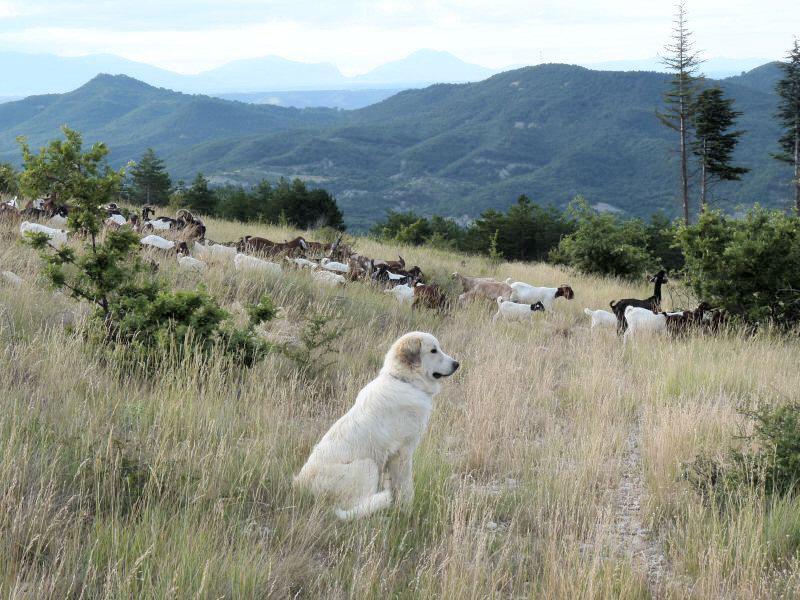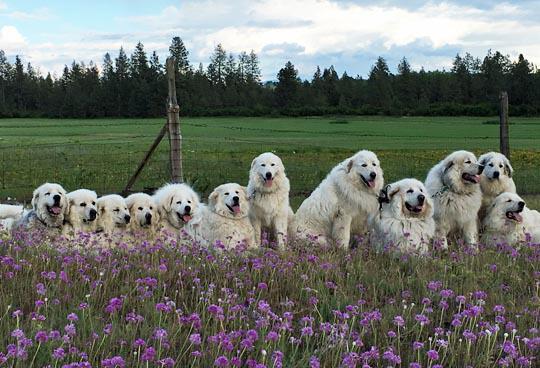The first image is the image on the left, the second image is the image on the right. Assess this claim about the two images: "In one image, one dog is shown with a flock of goats.". Correct or not? Answer yes or no. Yes. The first image is the image on the left, the second image is the image on the right. For the images shown, is this caption "There are exactly two dogs in the image on the right." true? Answer yes or no. No. 